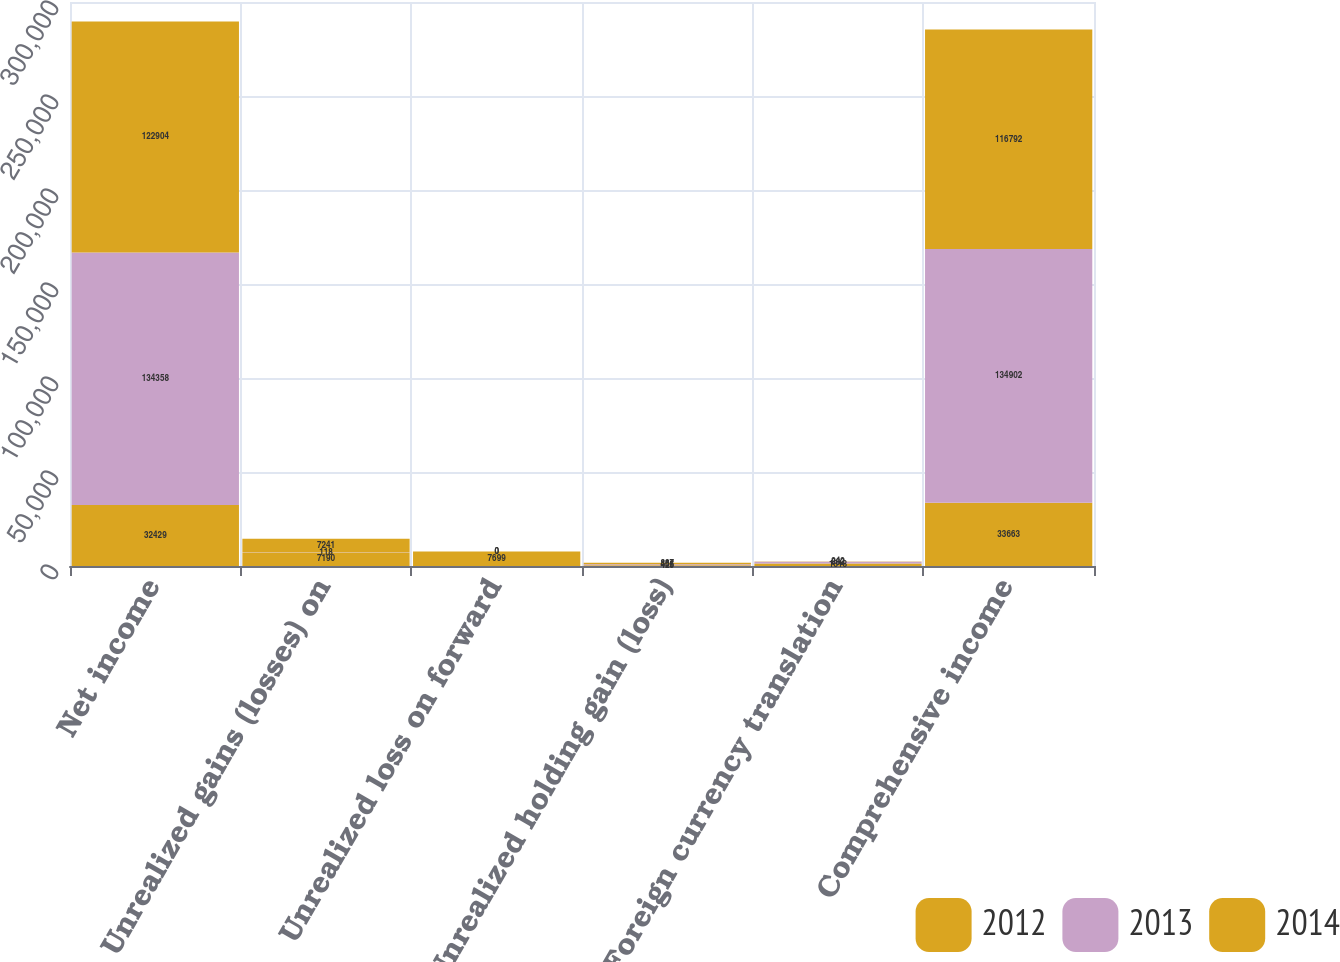Convert chart to OTSL. <chart><loc_0><loc_0><loc_500><loc_500><stacked_bar_chart><ecel><fcel>Net income<fcel>Unrealized gains (losses) on<fcel>Unrealized loss on forward<fcel>Unrealized holding gain (loss)<fcel>Foreign currency translation<fcel>Comprehensive income<nl><fcel>2012<fcel>32429<fcel>7190<fcel>7699<fcel>425<fcel>1318<fcel>33663<nl><fcel>2013<fcel>134358<fcel>118<fcel>0<fcel>456<fcel>882<fcel>134902<nl><fcel>2014<fcel>122904<fcel>7241<fcel>0<fcel>887<fcel>242<fcel>116792<nl></chart> 